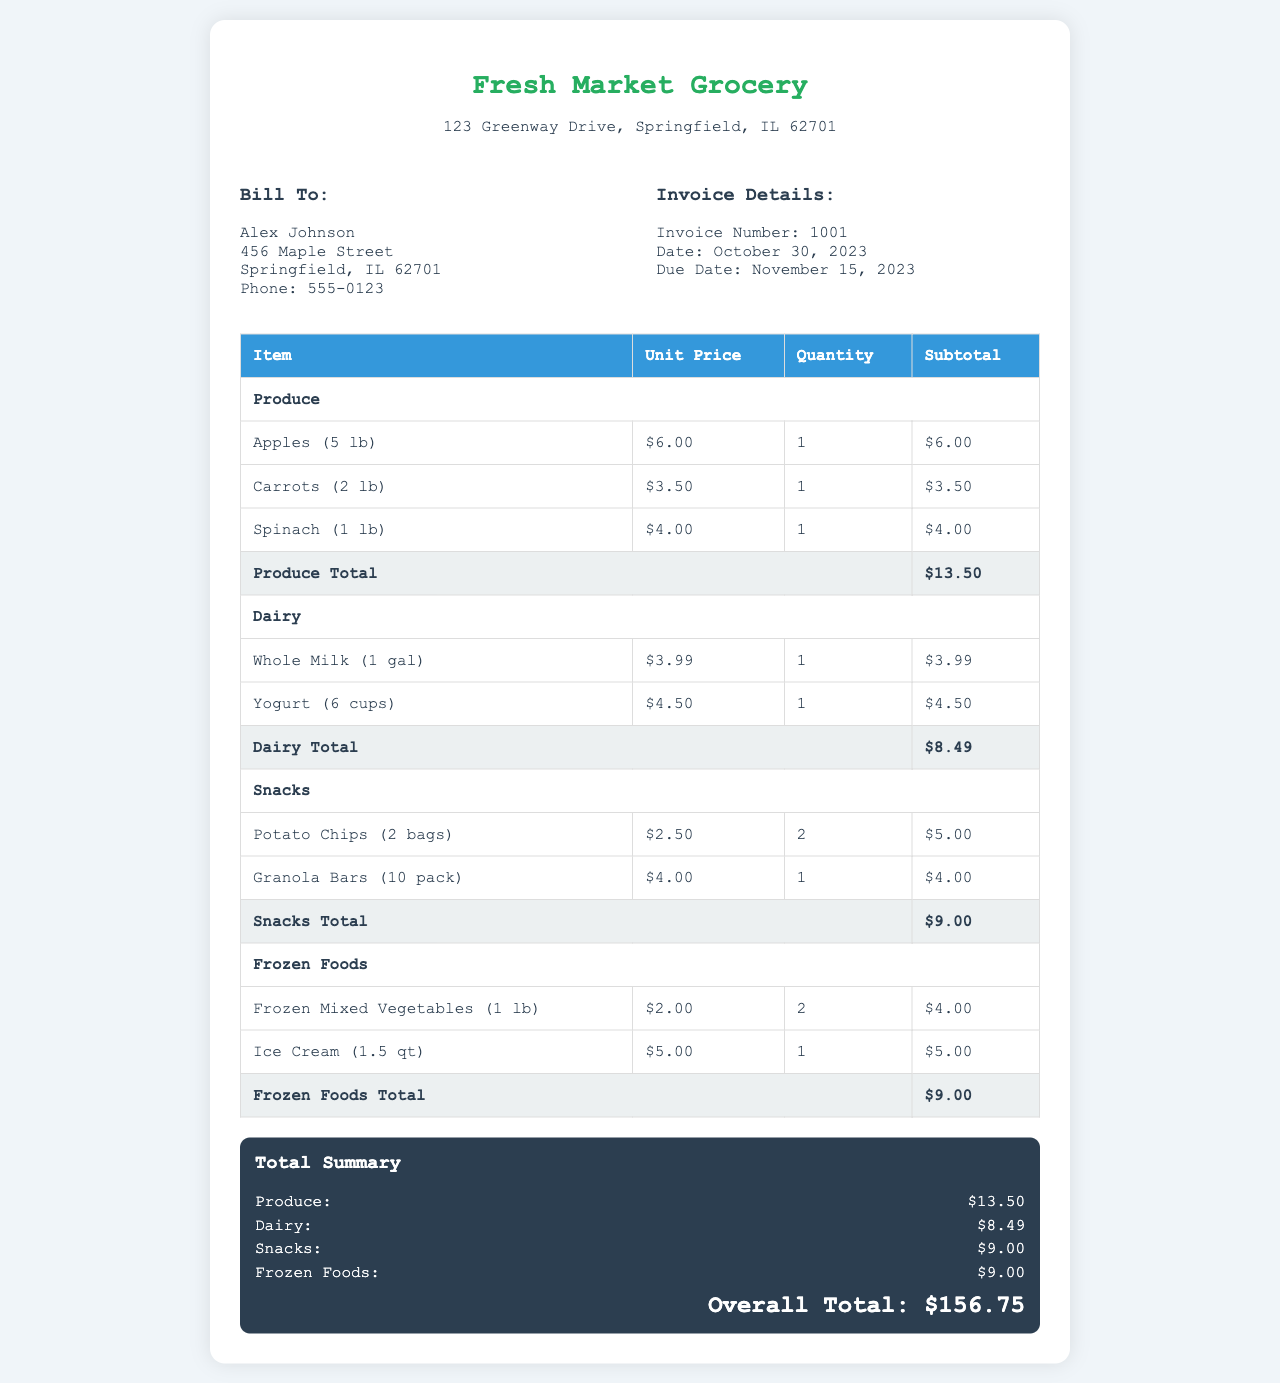What is the total amount of produce? The Produce Total is clearly stated in the invoice as $13.50.
Answer: $13.50 What is the due date of the invoice? The invoice states the due date is November 15, 2023.
Answer: November 15, 2023 Who is the bill to? The document provides the name and address for billing, which is Alex Johnson at 456 Maple Street, Springfield, IL 62701.
Answer: Alex Johnson What is the subtotal for dairy items? The Dairy Total is specified in the invoice as $8.49.
Answer: $8.49 How many bags of potato chips were purchased? The document indicates that 2 bags of potato chips were purchased, as specified in the Snacks section.
Answer: 2 What is the overall total amount for the invoice? The overall total at the end of the invoice is clearly stated as $156.75.
Answer: $156.75 What quantity of spinach was purchased? The invoice shows that 1 lb of spinach was purchased.
Answer: 1 lb Which category has the highest total? To determine this, we compare the totals of each category, and the highest among them is Produce with a total of $13.50.
Answer: Produce What items are listed under Frozen Foods? The invoice lists Frozen Mixed Vegetables and Ice Cream under the Frozen Foods category.
Answer: Frozen Mixed Vegetables, Ice Cream 